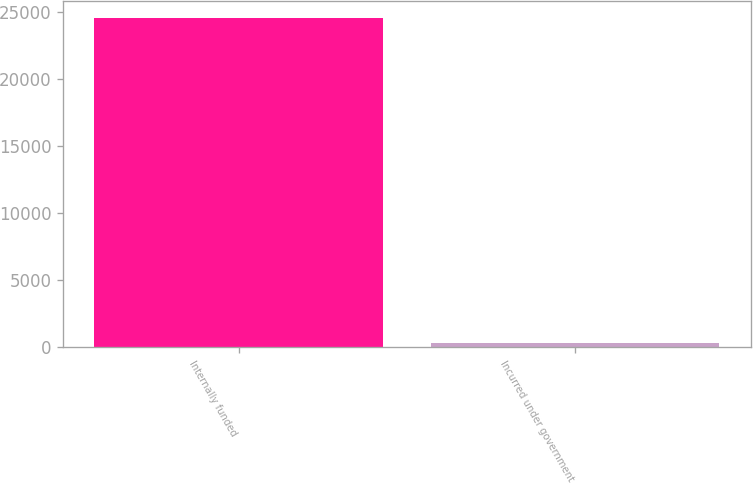Convert chart. <chart><loc_0><loc_0><loc_500><loc_500><bar_chart><fcel>Internally funded<fcel>Incurred under government<nl><fcel>24588<fcel>329<nl></chart> 